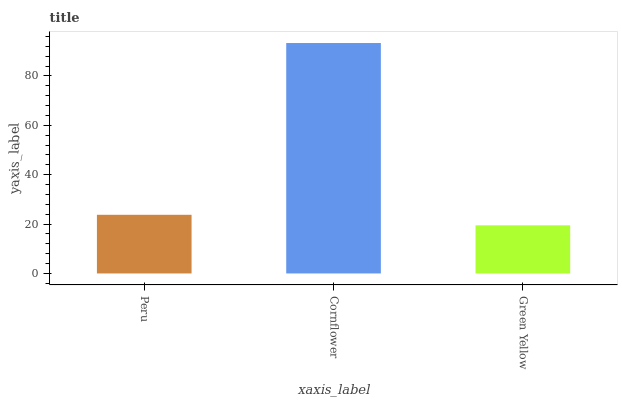Is Green Yellow the minimum?
Answer yes or no. Yes. Is Cornflower the maximum?
Answer yes or no. Yes. Is Cornflower the minimum?
Answer yes or no. No. Is Green Yellow the maximum?
Answer yes or no. No. Is Cornflower greater than Green Yellow?
Answer yes or no. Yes. Is Green Yellow less than Cornflower?
Answer yes or no. Yes. Is Green Yellow greater than Cornflower?
Answer yes or no. No. Is Cornflower less than Green Yellow?
Answer yes or no. No. Is Peru the high median?
Answer yes or no. Yes. Is Peru the low median?
Answer yes or no. Yes. Is Cornflower the high median?
Answer yes or no. No. Is Green Yellow the low median?
Answer yes or no. No. 